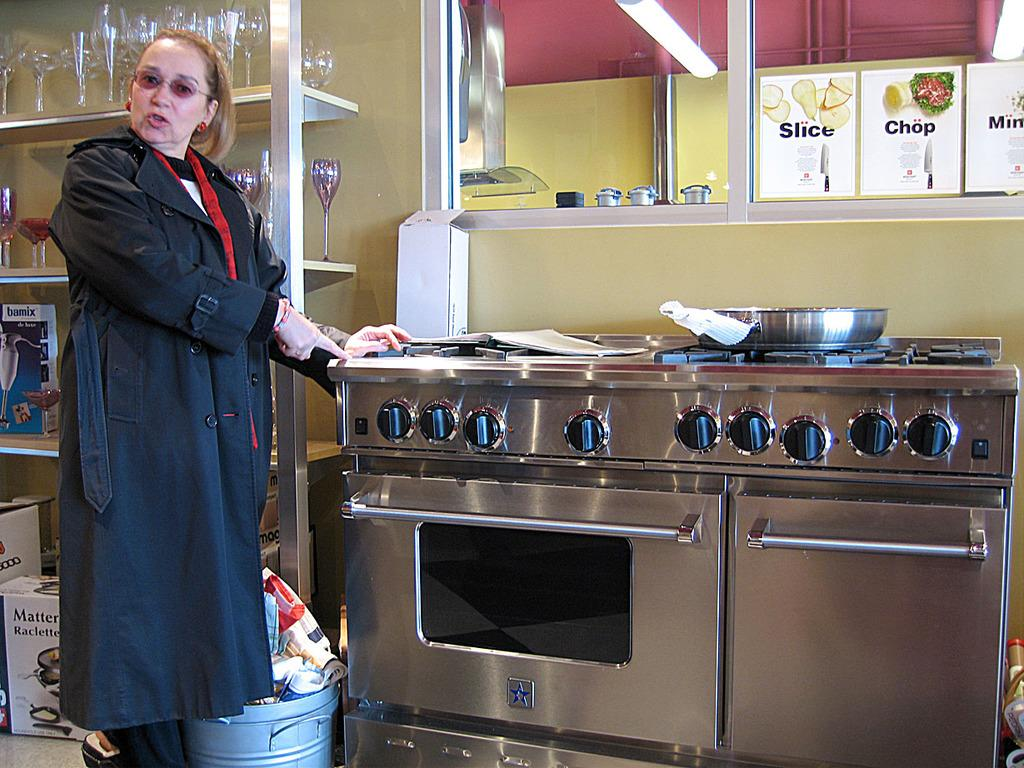Provide a one-sentence caption for the provided image. signs above a stove that says 'slice' and 'chop' on them. 